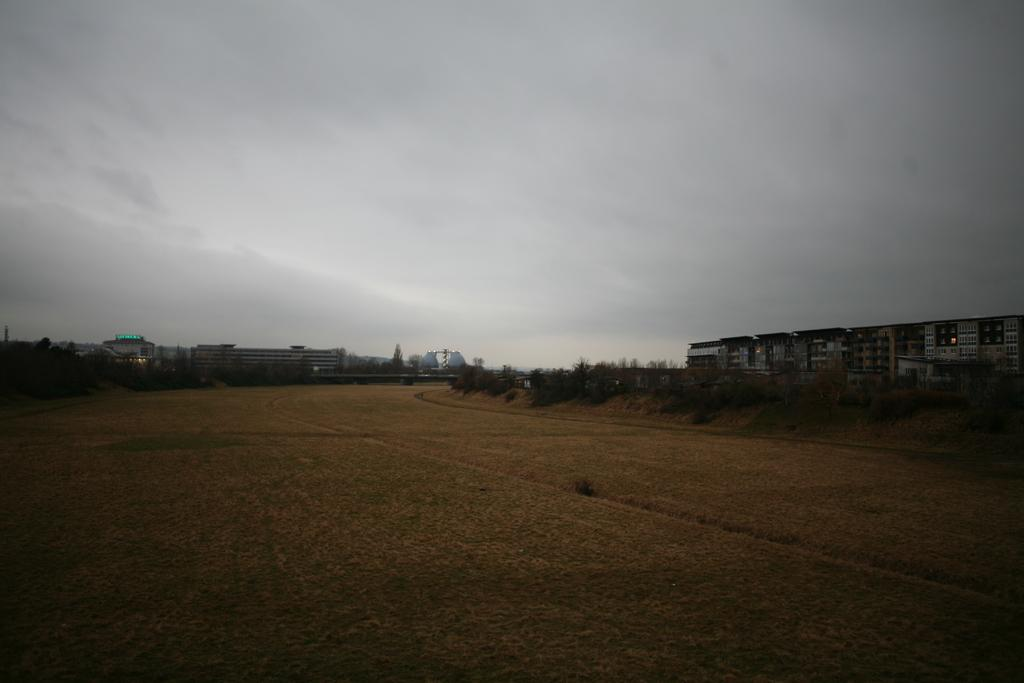What type of landscape is depicted in the image? There is an open land in the image. Where are the buildings located in the image? The buildings are on the right side of the image. What can be seen in the background of the image? The sky is visible in the background of the image. What type of wheel is used by the person in the image? There are no people or wheels present in the image; it features an open land with buildings and a visible sky. 